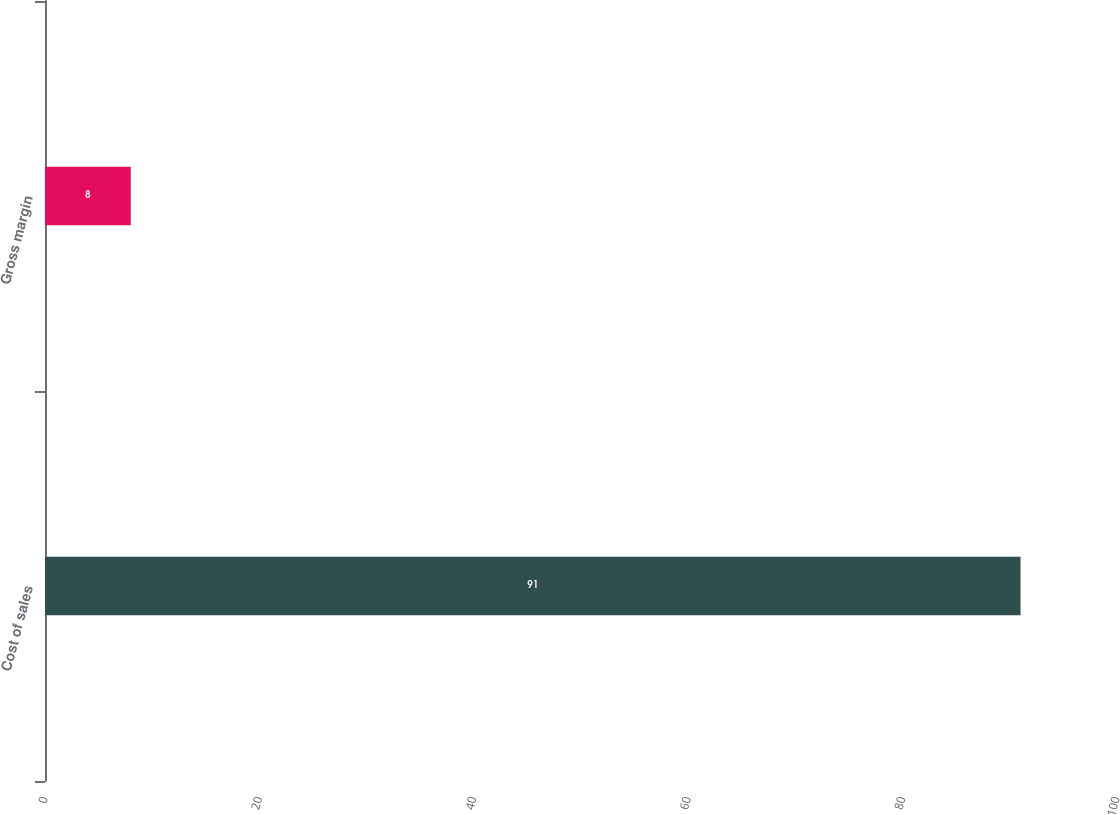Convert chart to OTSL. <chart><loc_0><loc_0><loc_500><loc_500><bar_chart><fcel>Cost of sales<fcel>Gross margin<nl><fcel>91<fcel>8<nl></chart> 